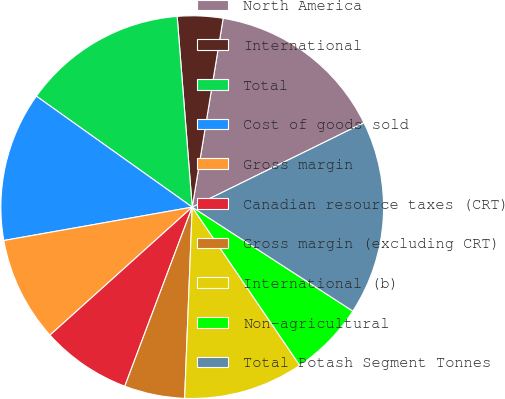<chart> <loc_0><loc_0><loc_500><loc_500><pie_chart><fcel>North America<fcel>International<fcel>Total<fcel>Cost of goods sold<fcel>Gross margin<fcel>Canadian resource taxes (CRT)<fcel>Gross margin (excluding CRT)<fcel>International (b)<fcel>Non-agricultural<fcel>Total Potash Segment Tonnes<nl><fcel>15.15%<fcel>3.84%<fcel>13.9%<fcel>12.64%<fcel>8.87%<fcel>7.61%<fcel>5.1%<fcel>10.13%<fcel>6.36%<fcel>16.41%<nl></chart> 